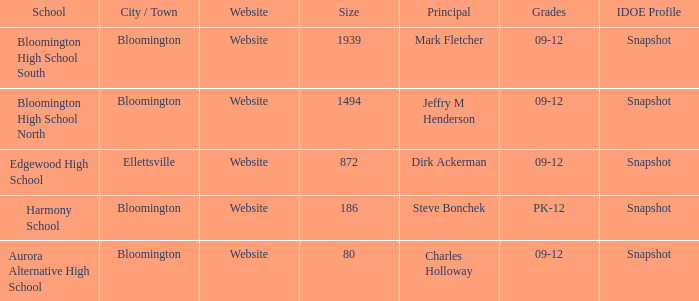Where is Bloomington High School North? Bloomington. 